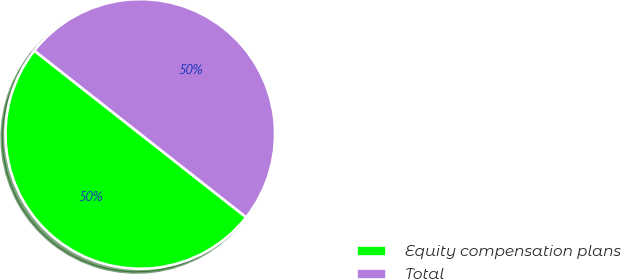Convert chart to OTSL. <chart><loc_0><loc_0><loc_500><loc_500><pie_chart><fcel>Equity compensation plans<fcel>Total<nl><fcel>50.0%<fcel>50.0%<nl></chart> 